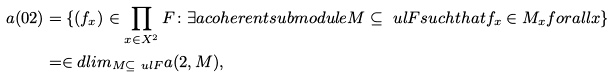<formula> <loc_0><loc_0><loc_500><loc_500>a ( 0 2 ) & = \{ ( f _ { x } ) \in \prod _ { x \in X ^ { 2 } } F \colon \exists a c o h e r e n t s u b m o d u l e M \subseteq \ u l { F } s u c h t h a t f _ { x } \in M _ { x } f o r a l l x \} \\ & = \in d l i m _ { M \subseteq \ u l { F } } a ( 2 , M ) ,</formula> 